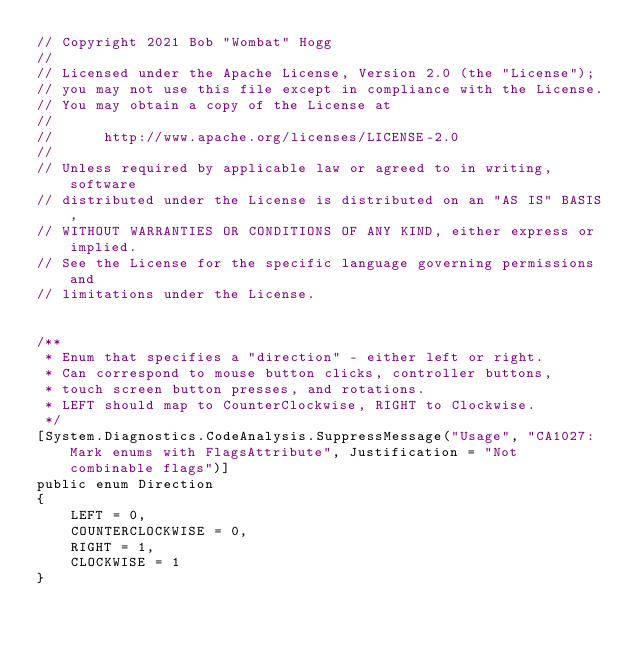<code> <loc_0><loc_0><loc_500><loc_500><_C#_>// Copyright 2021 Bob "Wombat" Hogg
//
// Licensed under the Apache License, Version 2.0 (the "License");
// you may not use this file except in compliance with the License.
// You may obtain a copy of the License at
//
//      http://www.apache.org/licenses/LICENSE-2.0
//
// Unless required by applicable law or agreed to in writing, software
// distributed under the License is distributed on an "AS IS" BASIS,
// WITHOUT WARRANTIES OR CONDITIONS OF ANY KIND, either express or implied.
// See the License for the specific language governing permissions and
// limitations under the License.


/**
 * Enum that specifies a "direction" - either left or right.
 * Can correspond to mouse button clicks, controller buttons,
 * touch screen button presses, and rotations.
 * LEFT should map to CounterClockwise, RIGHT to Clockwise.
 */
[System.Diagnostics.CodeAnalysis.SuppressMessage("Usage", "CA1027:Mark enums with FlagsAttribute", Justification = "Not combinable flags")]
public enum Direction
{
    LEFT = 0,
    COUNTERCLOCKWISE = 0,
    RIGHT = 1,
    CLOCKWISE = 1
}
</code> 